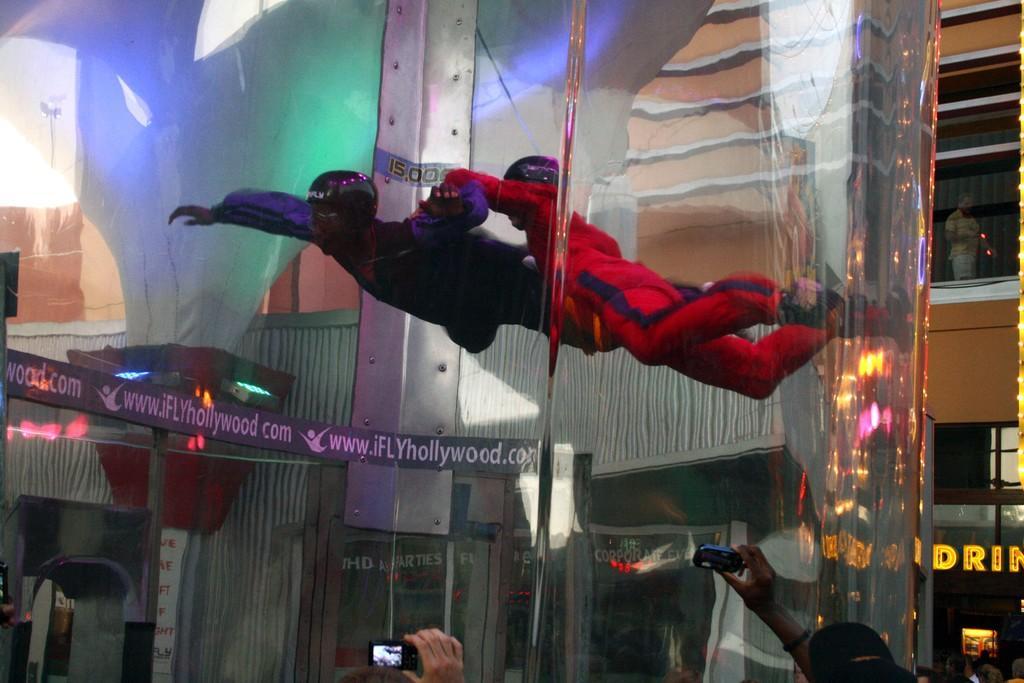Could you give a brief overview of what you see in this image? In this picture we can see a few people holding objects in their hands. We can see two people flying in a transparent object. There is some text and a few things on the boards. We can some people, lights and other objects. 